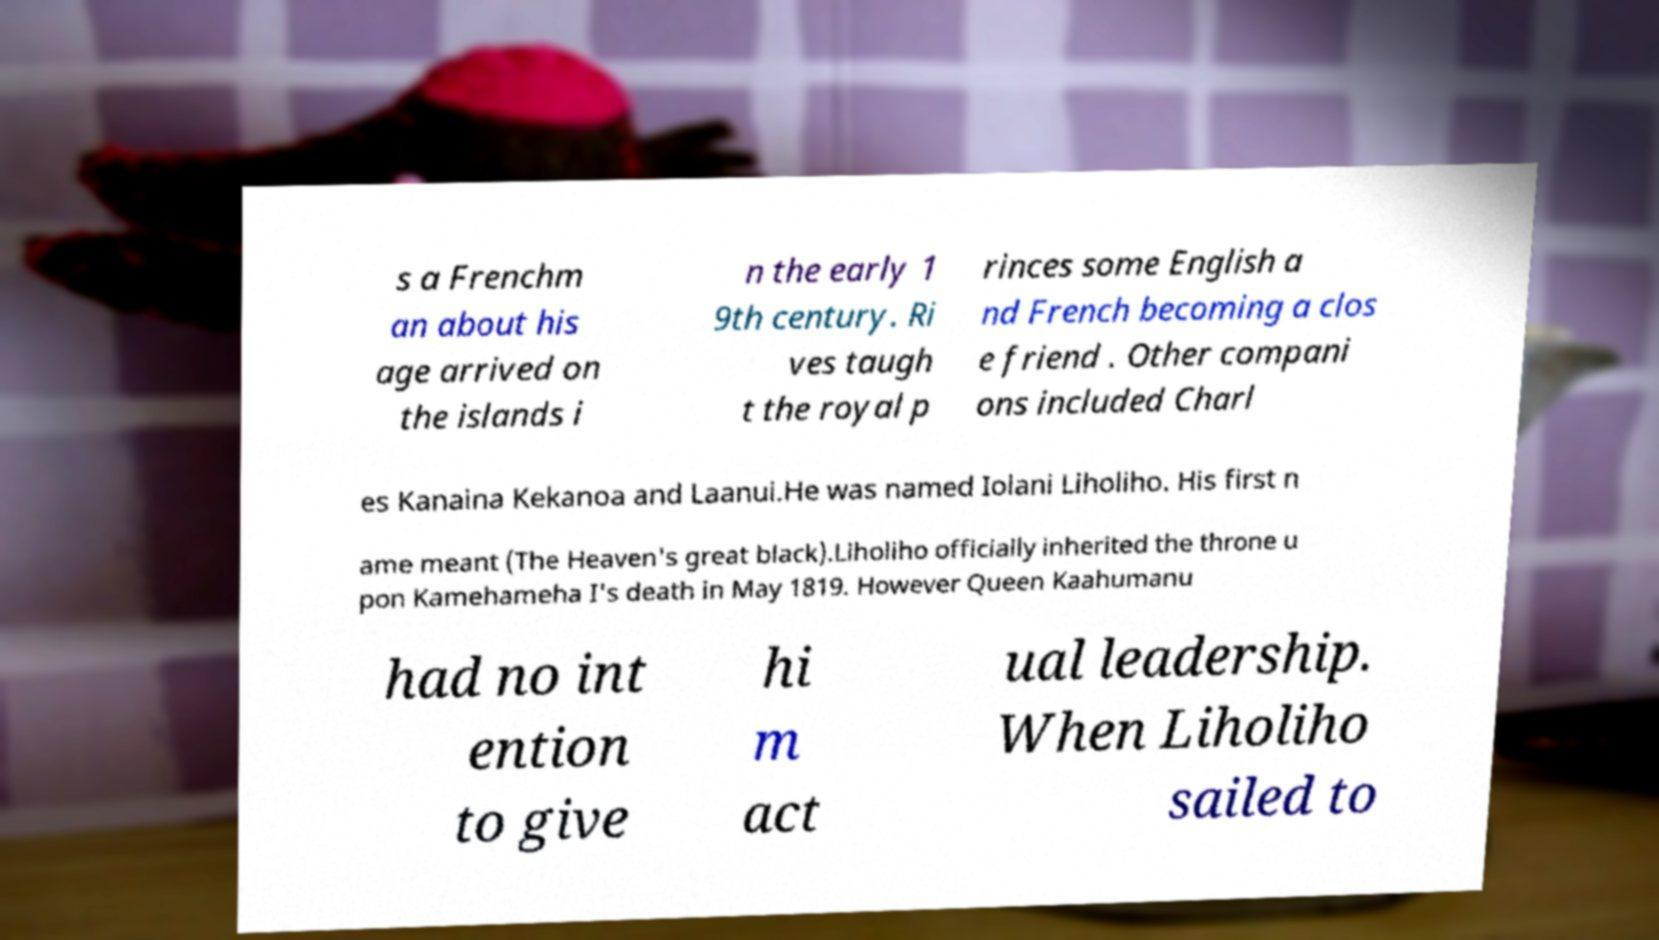Please read and relay the text visible in this image. What does it say? s a Frenchm an about his age arrived on the islands i n the early 1 9th century. Ri ves taugh t the royal p rinces some English a nd French becoming a clos e friend . Other compani ons included Charl es Kanaina Kekanoa and Laanui.He was named Iolani Liholiho. His first n ame meant (The Heaven's great black).Liholiho officially inherited the throne u pon Kamehameha I's death in May 1819. However Queen Kaahumanu had no int ention to give hi m act ual leadership. When Liholiho sailed to 